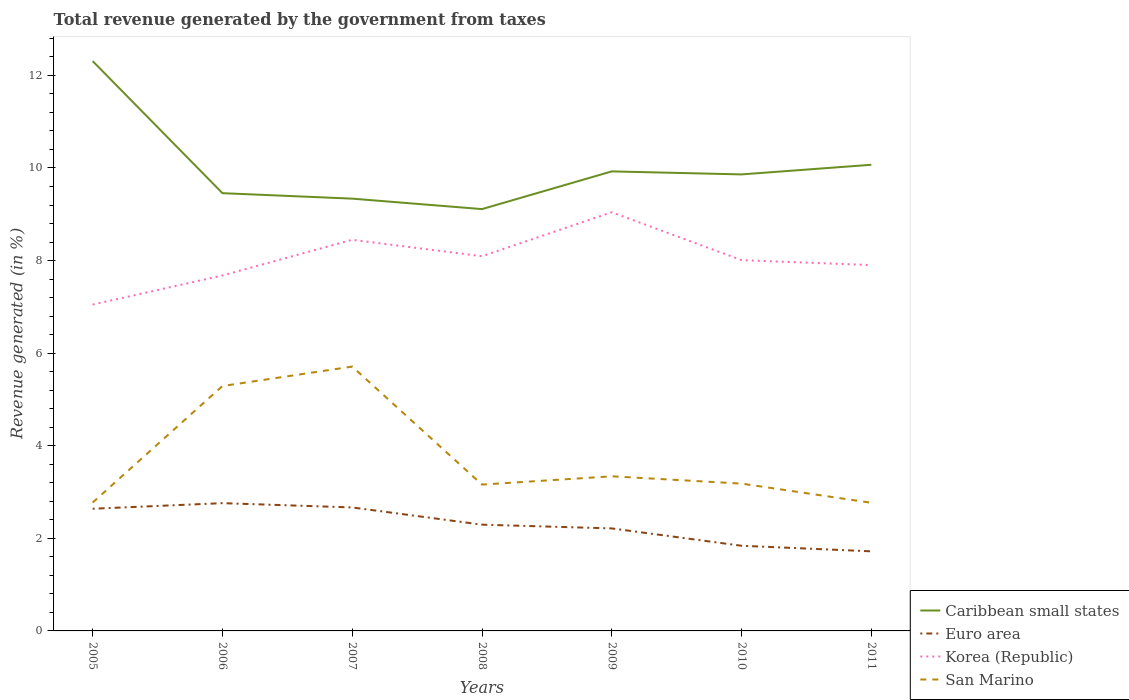Does the line corresponding to Caribbean small states intersect with the line corresponding to Euro area?
Your answer should be compact. No. Is the number of lines equal to the number of legend labels?
Give a very brief answer. Yes. Across all years, what is the maximum total revenue generated in Korea (Republic)?
Offer a terse response. 7.05. In which year was the total revenue generated in San Marino maximum?
Give a very brief answer. 2011. What is the total total revenue generated in Korea (Republic) in the graph?
Your answer should be compact. -1.04. What is the difference between the highest and the second highest total revenue generated in Caribbean small states?
Offer a very short reply. 3.2. What is the difference between the highest and the lowest total revenue generated in Caribbean small states?
Your response must be concise. 2. Does the graph contain grids?
Your response must be concise. No. Where does the legend appear in the graph?
Give a very brief answer. Bottom right. How many legend labels are there?
Give a very brief answer. 4. How are the legend labels stacked?
Your answer should be compact. Vertical. What is the title of the graph?
Keep it short and to the point. Total revenue generated by the government from taxes. Does "Marshall Islands" appear as one of the legend labels in the graph?
Your answer should be very brief. No. What is the label or title of the X-axis?
Offer a very short reply. Years. What is the label or title of the Y-axis?
Offer a very short reply. Revenue generated (in %). What is the Revenue generated (in %) of Caribbean small states in 2005?
Your answer should be compact. 12.31. What is the Revenue generated (in %) of Euro area in 2005?
Give a very brief answer. 2.64. What is the Revenue generated (in %) of Korea (Republic) in 2005?
Make the answer very short. 7.05. What is the Revenue generated (in %) in San Marino in 2005?
Make the answer very short. 2.77. What is the Revenue generated (in %) of Caribbean small states in 2006?
Your answer should be compact. 9.46. What is the Revenue generated (in %) in Euro area in 2006?
Ensure brevity in your answer.  2.76. What is the Revenue generated (in %) of Korea (Republic) in 2006?
Give a very brief answer. 7.68. What is the Revenue generated (in %) of San Marino in 2006?
Offer a very short reply. 5.29. What is the Revenue generated (in %) in Caribbean small states in 2007?
Provide a succinct answer. 9.34. What is the Revenue generated (in %) in Euro area in 2007?
Offer a very short reply. 2.67. What is the Revenue generated (in %) in Korea (Republic) in 2007?
Your answer should be very brief. 8.45. What is the Revenue generated (in %) in San Marino in 2007?
Your answer should be very brief. 5.71. What is the Revenue generated (in %) of Caribbean small states in 2008?
Keep it short and to the point. 9.11. What is the Revenue generated (in %) in Euro area in 2008?
Your answer should be very brief. 2.3. What is the Revenue generated (in %) in Korea (Republic) in 2008?
Keep it short and to the point. 8.09. What is the Revenue generated (in %) in San Marino in 2008?
Your answer should be compact. 3.16. What is the Revenue generated (in %) of Caribbean small states in 2009?
Keep it short and to the point. 9.93. What is the Revenue generated (in %) of Euro area in 2009?
Your answer should be very brief. 2.21. What is the Revenue generated (in %) of Korea (Republic) in 2009?
Provide a short and direct response. 9.04. What is the Revenue generated (in %) in San Marino in 2009?
Keep it short and to the point. 3.34. What is the Revenue generated (in %) in Caribbean small states in 2010?
Give a very brief answer. 9.86. What is the Revenue generated (in %) of Euro area in 2010?
Keep it short and to the point. 1.84. What is the Revenue generated (in %) in Korea (Republic) in 2010?
Offer a very short reply. 8.01. What is the Revenue generated (in %) in San Marino in 2010?
Provide a succinct answer. 3.18. What is the Revenue generated (in %) of Caribbean small states in 2011?
Provide a succinct answer. 10.07. What is the Revenue generated (in %) of Euro area in 2011?
Keep it short and to the point. 1.72. What is the Revenue generated (in %) in Korea (Republic) in 2011?
Give a very brief answer. 7.9. What is the Revenue generated (in %) in San Marino in 2011?
Keep it short and to the point. 2.77. Across all years, what is the maximum Revenue generated (in %) of Caribbean small states?
Provide a short and direct response. 12.31. Across all years, what is the maximum Revenue generated (in %) of Euro area?
Make the answer very short. 2.76. Across all years, what is the maximum Revenue generated (in %) of Korea (Republic)?
Provide a succinct answer. 9.04. Across all years, what is the maximum Revenue generated (in %) in San Marino?
Keep it short and to the point. 5.71. Across all years, what is the minimum Revenue generated (in %) of Caribbean small states?
Provide a short and direct response. 9.11. Across all years, what is the minimum Revenue generated (in %) in Euro area?
Provide a succinct answer. 1.72. Across all years, what is the minimum Revenue generated (in %) of Korea (Republic)?
Provide a short and direct response. 7.05. Across all years, what is the minimum Revenue generated (in %) in San Marino?
Offer a terse response. 2.77. What is the total Revenue generated (in %) of Caribbean small states in the graph?
Give a very brief answer. 70.07. What is the total Revenue generated (in %) in Euro area in the graph?
Ensure brevity in your answer.  16.13. What is the total Revenue generated (in %) of Korea (Republic) in the graph?
Keep it short and to the point. 56.23. What is the total Revenue generated (in %) in San Marino in the graph?
Your answer should be compact. 26.22. What is the difference between the Revenue generated (in %) in Caribbean small states in 2005 and that in 2006?
Provide a succinct answer. 2.85. What is the difference between the Revenue generated (in %) of Euro area in 2005 and that in 2006?
Give a very brief answer. -0.12. What is the difference between the Revenue generated (in %) of Korea (Republic) in 2005 and that in 2006?
Your response must be concise. -0.63. What is the difference between the Revenue generated (in %) in San Marino in 2005 and that in 2006?
Your answer should be very brief. -2.52. What is the difference between the Revenue generated (in %) of Caribbean small states in 2005 and that in 2007?
Ensure brevity in your answer.  2.97. What is the difference between the Revenue generated (in %) of Euro area in 2005 and that in 2007?
Give a very brief answer. -0.03. What is the difference between the Revenue generated (in %) of Korea (Republic) in 2005 and that in 2007?
Your answer should be very brief. -1.4. What is the difference between the Revenue generated (in %) of San Marino in 2005 and that in 2007?
Provide a short and direct response. -2.94. What is the difference between the Revenue generated (in %) of Caribbean small states in 2005 and that in 2008?
Give a very brief answer. 3.2. What is the difference between the Revenue generated (in %) in Euro area in 2005 and that in 2008?
Keep it short and to the point. 0.34. What is the difference between the Revenue generated (in %) in Korea (Republic) in 2005 and that in 2008?
Your response must be concise. -1.04. What is the difference between the Revenue generated (in %) of San Marino in 2005 and that in 2008?
Ensure brevity in your answer.  -0.39. What is the difference between the Revenue generated (in %) in Caribbean small states in 2005 and that in 2009?
Ensure brevity in your answer.  2.38. What is the difference between the Revenue generated (in %) in Euro area in 2005 and that in 2009?
Provide a short and direct response. 0.42. What is the difference between the Revenue generated (in %) in Korea (Republic) in 2005 and that in 2009?
Give a very brief answer. -1.99. What is the difference between the Revenue generated (in %) in San Marino in 2005 and that in 2009?
Give a very brief answer. -0.57. What is the difference between the Revenue generated (in %) in Caribbean small states in 2005 and that in 2010?
Provide a succinct answer. 2.45. What is the difference between the Revenue generated (in %) in Euro area in 2005 and that in 2010?
Provide a succinct answer. 0.8. What is the difference between the Revenue generated (in %) in Korea (Republic) in 2005 and that in 2010?
Provide a succinct answer. -0.96. What is the difference between the Revenue generated (in %) in San Marino in 2005 and that in 2010?
Give a very brief answer. -0.41. What is the difference between the Revenue generated (in %) in Caribbean small states in 2005 and that in 2011?
Give a very brief answer. 2.24. What is the difference between the Revenue generated (in %) of Euro area in 2005 and that in 2011?
Your response must be concise. 0.92. What is the difference between the Revenue generated (in %) of Korea (Republic) in 2005 and that in 2011?
Offer a very short reply. -0.85. What is the difference between the Revenue generated (in %) of San Marino in 2005 and that in 2011?
Give a very brief answer. 0.01. What is the difference between the Revenue generated (in %) in Caribbean small states in 2006 and that in 2007?
Provide a short and direct response. 0.12. What is the difference between the Revenue generated (in %) of Euro area in 2006 and that in 2007?
Provide a short and direct response. 0.09. What is the difference between the Revenue generated (in %) of Korea (Republic) in 2006 and that in 2007?
Ensure brevity in your answer.  -0.77. What is the difference between the Revenue generated (in %) in San Marino in 2006 and that in 2007?
Provide a short and direct response. -0.42. What is the difference between the Revenue generated (in %) in Caribbean small states in 2006 and that in 2008?
Provide a short and direct response. 0.34. What is the difference between the Revenue generated (in %) in Euro area in 2006 and that in 2008?
Provide a short and direct response. 0.46. What is the difference between the Revenue generated (in %) of Korea (Republic) in 2006 and that in 2008?
Provide a succinct answer. -0.42. What is the difference between the Revenue generated (in %) in San Marino in 2006 and that in 2008?
Give a very brief answer. 2.13. What is the difference between the Revenue generated (in %) in Caribbean small states in 2006 and that in 2009?
Offer a terse response. -0.47. What is the difference between the Revenue generated (in %) of Euro area in 2006 and that in 2009?
Offer a very short reply. 0.55. What is the difference between the Revenue generated (in %) in Korea (Republic) in 2006 and that in 2009?
Offer a terse response. -1.37. What is the difference between the Revenue generated (in %) of San Marino in 2006 and that in 2009?
Provide a short and direct response. 1.95. What is the difference between the Revenue generated (in %) in Caribbean small states in 2006 and that in 2010?
Keep it short and to the point. -0.41. What is the difference between the Revenue generated (in %) of Euro area in 2006 and that in 2010?
Make the answer very short. 0.92. What is the difference between the Revenue generated (in %) of Korea (Republic) in 2006 and that in 2010?
Offer a very short reply. -0.33. What is the difference between the Revenue generated (in %) of San Marino in 2006 and that in 2010?
Your answer should be compact. 2.11. What is the difference between the Revenue generated (in %) of Caribbean small states in 2006 and that in 2011?
Provide a succinct answer. -0.61. What is the difference between the Revenue generated (in %) of Euro area in 2006 and that in 2011?
Make the answer very short. 1.04. What is the difference between the Revenue generated (in %) of Korea (Republic) in 2006 and that in 2011?
Your answer should be compact. -0.22. What is the difference between the Revenue generated (in %) in San Marino in 2006 and that in 2011?
Make the answer very short. 2.52. What is the difference between the Revenue generated (in %) in Caribbean small states in 2007 and that in 2008?
Make the answer very short. 0.23. What is the difference between the Revenue generated (in %) in Euro area in 2007 and that in 2008?
Offer a terse response. 0.37. What is the difference between the Revenue generated (in %) in Korea (Republic) in 2007 and that in 2008?
Offer a terse response. 0.35. What is the difference between the Revenue generated (in %) in San Marino in 2007 and that in 2008?
Provide a short and direct response. 2.55. What is the difference between the Revenue generated (in %) in Caribbean small states in 2007 and that in 2009?
Keep it short and to the point. -0.59. What is the difference between the Revenue generated (in %) of Euro area in 2007 and that in 2009?
Offer a very short reply. 0.45. What is the difference between the Revenue generated (in %) of Korea (Republic) in 2007 and that in 2009?
Provide a short and direct response. -0.6. What is the difference between the Revenue generated (in %) in San Marino in 2007 and that in 2009?
Ensure brevity in your answer.  2.37. What is the difference between the Revenue generated (in %) in Caribbean small states in 2007 and that in 2010?
Keep it short and to the point. -0.52. What is the difference between the Revenue generated (in %) in Euro area in 2007 and that in 2010?
Offer a very short reply. 0.83. What is the difference between the Revenue generated (in %) of Korea (Republic) in 2007 and that in 2010?
Your answer should be compact. 0.44. What is the difference between the Revenue generated (in %) of San Marino in 2007 and that in 2010?
Your response must be concise. 2.53. What is the difference between the Revenue generated (in %) of Caribbean small states in 2007 and that in 2011?
Your response must be concise. -0.73. What is the difference between the Revenue generated (in %) in Euro area in 2007 and that in 2011?
Ensure brevity in your answer.  0.95. What is the difference between the Revenue generated (in %) of Korea (Republic) in 2007 and that in 2011?
Keep it short and to the point. 0.55. What is the difference between the Revenue generated (in %) in San Marino in 2007 and that in 2011?
Provide a succinct answer. 2.94. What is the difference between the Revenue generated (in %) in Caribbean small states in 2008 and that in 2009?
Give a very brief answer. -0.81. What is the difference between the Revenue generated (in %) of Euro area in 2008 and that in 2009?
Make the answer very short. 0.08. What is the difference between the Revenue generated (in %) of Korea (Republic) in 2008 and that in 2009?
Provide a short and direct response. -0.95. What is the difference between the Revenue generated (in %) in San Marino in 2008 and that in 2009?
Give a very brief answer. -0.18. What is the difference between the Revenue generated (in %) in Caribbean small states in 2008 and that in 2010?
Offer a terse response. -0.75. What is the difference between the Revenue generated (in %) in Euro area in 2008 and that in 2010?
Provide a succinct answer. 0.46. What is the difference between the Revenue generated (in %) in Korea (Republic) in 2008 and that in 2010?
Provide a short and direct response. 0.09. What is the difference between the Revenue generated (in %) of San Marino in 2008 and that in 2010?
Your response must be concise. -0.02. What is the difference between the Revenue generated (in %) of Caribbean small states in 2008 and that in 2011?
Keep it short and to the point. -0.96. What is the difference between the Revenue generated (in %) of Euro area in 2008 and that in 2011?
Your answer should be compact. 0.58. What is the difference between the Revenue generated (in %) of Korea (Republic) in 2008 and that in 2011?
Your answer should be very brief. 0.19. What is the difference between the Revenue generated (in %) of San Marino in 2008 and that in 2011?
Provide a short and direct response. 0.39. What is the difference between the Revenue generated (in %) in Caribbean small states in 2009 and that in 2010?
Give a very brief answer. 0.07. What is the difference between the Revenue generated (in %) of Euro area in 2009 and that in 2010?
Your answer should be very brief. 0.37. What is the difference between the Revenue generated (in %) in Korea (Republic) in 2009 and that in 2010?
Provide a short and direct response. 1.04. What is the difference between the Revenue generated (in %) in San Marino in 2009 and that in 2010?
Give a very brief answer. 0.16. What is the difference between the Revenue generated (in %) of Caribbean small states in 2009 and that in 2011?
Ensure brevity in your answer.  -0.14. What is the difference between the Revenue generated (in %) in Euro area in 2009 and that in 2011?
Your answer should be compact. 0.49. What is the difference between the Revenue generated (in %) in Korea (Republic) in 2009 and that in 2011?
Offer a very short reply. 1.14. What is the difference between the Revenue generated (in %) of San Marino in 2009 and that in 2011?
Keep it short and to the point. 0.57. What is the difference between the Revenue generated (in %) in Caribbean small states in 2010 and that in 2011?
Your answer should be very brief. -0.21. What is the difference between the Revenue generated (in %) in Euro area in 2010 and that in 2011?
Your response must be concise. 0.12. What is the difference between the Revenue generated (in %) in Korea (Republic) in 2010 and that in 2011?
Offer a very short reply. 0.11. What is the difference between the Revenue generated (in %) of San Marino in 2010 and that in 2011?
Ensure brevity in your answer.  0.41. What is the difference between the Revenue generated (in %) in Caribbean small states in 2005 and the Revenue generated (in %) in Euro area in 2006?
Offer a very short reply. 9.55. What is the difference between the Revenue generated (in %) of Caribbean small states in 2005 and the Revenue generated (in %) of Korea (Republic) in 2006?
Make the answer very short. 4.63. What is the difference between the Revenue generated (in %) of Caribbean small states in 2005 and the Revenue generated (in %) of San Marino in 2006?
Ensure brevity in your answer.  7.02. What is the difference between the Revenue generated (in %) of Euro area in 2005 and the Revenue generated (in %) of Korea (Republic) in 2006?
Make the answer very short. -5.04. What is the difference between the Revenue generated (in %) of Euro area in 2005 and the Revenue generated (in %) of San Marino in 2006?
Your answer should be very brief. -2.65. What is the difference between the Revenue generated (in %) in Korea (Republic) in 2005 and the Revenue generated (in %) in San Marino in 2006?
Make the answer very short. 1.76. What is the difference between the Revenue generated (in %) in Caribbean small states in 2005 and the Revenue generated (in %) in Euro area in 2007?
Provide a short and direct response. 9.64. What is the difference between the Revenue generated (in %) in Caribbean small states in 2005 and the Revenue generated (in %) in Korea (Republic) in 2007?
Your answer should be very brief. 3.86. What is the difference between the Revenue generated (in %) in Caribbean small states in 2005 and the Revenue generated (in %) in San Marino in 2007?
Your response must be concise. 6.6. What is the difference between the Revenue generated (in %) in Euro area in 2005 and the Revenue generated (in %) in Korea (Republic) in 2007?
Give a very brief answer. -5.81. What is the difference between the Revenue generated (in %) of Euro area in 2005 and the Revenue generated (in %) of San Marino in 2007?
Offer a very short reply. -3.07. What is the difference between the Revenue generated (in %) of Korea (Republic) in 2005 and the Revenue generated (in %) of San Marino in 2007?
Provide a succinct answer. 1.34. What is the difference between the Revenue generated (in %) of Caribbean small states in 2005 and the Revenue generated (in %) of Euro area in 2008?
Your response must be concise. 10.01. What is the difference between the Revenue generated (in %) of Caribbean small states in 2005 and the Revenue generated (in %) of Korea (Republic) in 2008?
Keep it short and to the point. 4.21. What is the difference between the Revenue generated (in %) in Caribbean small states in 2005 and the Revenue generated (in %) in San Marino in 2008?
Offer a terse response. 9.15. What is the difference between the Revenue generated (in %) in Euro area in 2005 and the Revenue generated (in %) in Korea (Republic) in 2008?
Offer a terse response. -5.46. What is the difference between the Revenue generated (in %) of Euro area in 2005 and the Revenue generated (in %) of San Marino in 2008?
Provide a succinct answer. -0.52. What is the difference between the Revenue generated (in %) of Korea (Republic) in 2005 and the Revenue generated (in %) of San Marino in 2008?
Ensure brevity in your answer.  3.89. What is the difference between the Revenue generated (in %) of Caribbean small states in 2005 and the Revenue generated (in %) of Euro area in 2009?
Provide a succinct answer. 10.09. What is the difference between the Revenue generated (in %) of Caribbean small states in 2005 and the Revenue generated (in %) of Korea (Republic) in 2009?
Ensure brevity in your answer.  3.26. What is the difference between the Revenue generated (in %) in Caribbean small states in 2005 and the Revenue generated (in %) in San Marino in 2009?
Offer a terse response. 8.97. What is the difference between the Revenue generated (in %) in Euro area in 2005 and the Revenue generated (in %) in Korea (Republic) in 2009?
Make the answer very short. -6.41. What is the difference between the Revenue generated (in %) in Euro area in 2005 and the Revenue generated (in %) in San Marino in 2009?
Give a very brief answer. -0.7. What is the difference between the Revenue generated (in %) of Korea (Republic) in 2005 and the Revenue generated (in %) of San Marino in 2009?
Provide a short and direct response. 3.71. What is the difference between the Revenue generated (in %) in Caribbean small states in 2005 and the Revenue generated (in %) in Euro area in 2010?
Offer a very short reply. 10.47. What is the difference between the Revenue generated (in %) of Caribbean small states in 2005 and the Revenue generated (in %) of Korea (Republic) in 2010?
Provide a short and direct response. 4.3. What is the difference between the Revenue generated (in %) in Caribbean small states in 2005 and the Revenue generated (in %) in San Marino in 2010?
Give a very brief answer. 9.13. What is the difference between the Revenue generated (in %) in Euro area in 2005 and the Revenue generated (in %) in Korea (Republic) in 2010?
Your answer should be compact. -5.37. What is the difference between the Revenue generated (in %) in Euro area in 2005 and the Revenue generated (in %) in San Marino in 2010?
Offer a terse response. -0.54. What is the difference between the Revenue generated (in %) of Korea (Republic) in 2005 and the Revenue generated (in %) of San Marino in 2010?
Give a very brief answer. 3.87. What is the difference between the Revenue generated (in %) of Caribbean small states in 2005 and the Revenue generated (in %) of Euro area in 2011?
Your answer should be very brief. 10.59. What is the difference between the Revenue generated (in %) in Caribbean small states in 2005 and the Revenue generated (in %) in Korea (Republic) in 2011?
Ensure brevity in your answer.  4.41. What is the difference between the Revenue generated (in %) of Caribbean small states in 2005 and the Revenue generated (in %) of San Marino in 2011?
Offer a very short reply. 9.54. What is the difference between the Revenue generated (in %) in Euro area in 2005 and the Revenue generated (in %) in Korea (Republic) in 2011?
Provide a short and direct response. -5.26. What is the difference between the Revenue generated (in %) of Euro area in 2005 and the Revenue generated (in %) of San Marino in 2011?
Provide a short and direct response. -0.13. What is the difference between the Revenue generated (in %) in Korea (Republic) in 2005 and the Revenue generated (in %) in San Marino in 2011?
Provide a short and direct response. 4.28. What is the difference between the Revenue generated (in %) in Caribbean small states in 2006 and the Revenue generated (in %) in Euro area in 2007?
Make the answer very short. 6.79. What is the difference between the Revenue generated (in %) of Caribbean small states in 2006 and the Revenue generated (in %) of Korea (Republic) in 2007?
Make the answer very short. 1.01. What is the difference between the Revenue generated (in %) in Caribbean small states in 2006 and the Revenue generated (in %) in San Marino in 2007?
Offer a terse response. 3.75. What is the difference between the Revenue generated (in %) of Euro area in 2006 and the Revenue generated (in %) of Korea (Republic) in 2007?
Ensure brevity in your answer.  -5.69. What is the difference between the Revenue generated (in %) of Euro area in 2006 and the Revenue generated (in %) of San Marino in 2007?
Ensure brevity in your answer.  -2.95. What is the difference between the Revenue generated (in %) of Korea (Republic) in 2006 and the Revenue generated (in %) of San Marino in 2007?
Make the answer very short. 1.97. What is the difference between the Revenue generated (in %) in Caribbean small states in 2006 and the Revenue generated (in %) in Euro area in 2008?
Your answer should be very brief. 7.16. What is the difference between the Revenue generated (in %) in Caribbean small states in 2006 and the Revenue generated (in %) in Korea (Republic) in 2008?
Provide a short and direct response. 1.36. What is the difference between the Revenue generated (in %) of Caribbean small states in 2006 and the Revenue generated (in %) of San Marino in 2008?
Keep it short and to the point. 6.29. What is the difference between the Revenue generated (in %) of Euro area in 2006 and the Revenue generated (in %) of Korea (Republic) in 2008?
Ensure brevity in your answer.  -5.33. What is the difference between the Revenue generated (in %) of Euro area in 2006 and the Revenue generated (in %) of San Marino in 2008?
Offer a terse response. -0.4. What is the difference between the Revenue generated (in %) in Korea (Republic) in 2006 and the Revenue generated (in %) in San Marino in 2008?
Offer a very short reply. 4.52. What is the difference between the Revenue generated (in %) in Caribbean small states in 2006 and the Revenue generated (in %) in Euro area in 2009?
Offer a terse response. 7.24. What is the difference between the Revenue generated (in %) in Caribbean small states in 2006 and the Revenue generated (in %) in Korea (Republic) in 2009?
Offer a very short reply. 0.41. What is the difference between the Revenue generated (in %) of Caribbean small states in 2006 and the Revenue generated (in %) of San Marino in 2009?
Ensure brevity in your answer.  6.12. What is the difference between the Revenue generated (in %) of Euro area in 2006 and the Revenue generated (in %) of Korea (Republic) in 2009?
Keep it short and to the point. -6.28. What is the difference between the Revenue generated (in %) in Euro area in 2006 and the Revenue generated (in %) in San Marino in 2009?
Provide a short and direct response. -0.58. What is the difference between the Revenue generated (in %) of Korea (Republic) in 2006 and the Revenue generated (in %) of San Marino in 2009?
Keep it short and to the point. 4.34. What is the difference between the Revenue generated (in %) in Caribbean small states in 2006 and the Revenue generated (in %) in Euro area in 2010?
Provide a succinct answer. 7.62. What is the difference between the Revenue generated (in %) in Caribbean small states in 2006 and the Revenue generated (in %) in Korea (Republic) in 2010?
Keep it short and to the point. 1.45. What is the difference between the Revenue generated (in %) of Caribbean small states in 2006 and the Revenue generated (in %) of San Marino in 2010?
Ensure brevity in your answer.  6.27. What is the difference between the Revenue generated (in %) in Euro area in 2006 and the Revenue generated (in %) in Korea (Republic) in 2010?
Provide a succinct answer. -5.25. What is the difference between the Revenue generated (in %) of Euro area in 2006 and the Revenue generated (in %) of San Marino in 2010?
Provide a short and direct response. -0.42. What is the difference between the Revenue generated (in %) of Korea (Republic) in 2006 and the Revenue generated (in %) of San Marino in 2010?
Ensure brevity in your answer.  4.5. What is the difference between the Revenue generated (in %) of Caribbean small states in 2006 and the Revenue generated (in %) of Euro area in 2011?
Keep it short and to the point. 7.74. What is the difference between the Revenue generated (in %) in Caribbean small states in 2006 and the Revenue generated (in %) in Korea (Republic) in 2011?
Your answer should be compact. 1.55. What is the difference between the Revenue generated (in %) of Caribbean small states in 2006 and the Revenue generated (in %) of San Marino in 2011?
Offer a very short reply. 6.69. What is the difference between the Revenue generated (in %) in Euro area in 2006 and the Revenue generated (in %) in Korea (Republic) in 2011?
Provide a succinct answer. -5.14. What is the difference between the Revenue generated (in %) in Euro area in 2006 and the Revenue generated (in %) in San Marino in 2011?
Your answer should be compact. -0.01. What is the difference between the Revenue generated (in %) of Korea (Republic) in 2006 and the Revenue generated (in %) of San Marino in 2011?
Make the answer very short. 4.91. What is the difference between the Revenue generated (in %) of Caribbean small states in 2007 and the Revenue generated (in %) of Euro area in 2008?
Provide a succinct answer. 7.04. What is the difference between the Revenue generated (in %) in Caribbean small states in 2007 and the Revenue generated (in %) in Korea (Republic) in 2008?
Provide a short and direct response. 1.24. What is the difference between the Revenue generated (in %) in Caribbean small states in 2007 and the Revenue generated (in %) in San Marino in 2008?
Give a very brief answer. 6.18. What is the difference between the Revenue generated (in %) of Euro area in 2007 and the Revenue generated (in %) of Korea (Republic) in 2008?
Keep it short and to the point. -5.43. What is the difference between the Revenue generated (in %) of Euro area in 2007 and the Revenue generated (in %) of San Marino in 2008?
Your answer should be very brief. -0.49. What is the difference between the Revenue generated (in %) of Korea (Republic) in 2007 and the Revenue generated (in %) of San Marino in 2008?
Provide a short and direct response. 5.29. What is the difference between the Revenue generated (in %) in Caribbean small states in 2007 and the Revenue generated (in %) in Euro area in 2009?
Give a very brief answer. 7.12. What is the difference between the Revenue generated (in %) of Caribbean small states in 2007 and the Revenue generated (in %) of Korea (Republic) in 2009?
Your response must be concise. 0.29. What is the difference between the Revenue generated (in %) in Caribbean small states in 2007 and the Revenue generated (in %) in San Marino in 2009?
Provide a succinct answer. 6. What is the difference between the Revenue generated (in %) in Euro area in 2007 and the Revenue generated (in %) in Korea (Republic) in 2009?
Your answer should be very brief. -6.38. What is the difference between the Revenue generated (in %) of Euro area in 2007 and the Revenue generated (in %) of San Marino in 2009?
Give a very brief answer. -0.67. What is the difference between the Revenue generated (in %) in Korea (Republic) in 2007 and the Revenue generated (in %) in San Marino in 2009?
Offer a terse response. 5.11. What is the difference between the Revenue generated (in %) of Caribbean small states in 2007 and the Revenue generated (in %) of Euro area in 2010?
Keep it short and to the point. 7.5. What is the difference between the Revenue generated (in %) of Caribbean small states in 2007 and the Revenue generated (in %) of Korea (Republic) in 2010?
Give a very brief answer. 1.33. What is the difference between the Revenue generated (in %) of Caribbean small states in 2007 and the Revenue generated (in %) of San Marino in 2010?
Your answer should be very brief. 6.16. What is the difference between the Revenue generated (in %) of Euro area in 2007 and the Revenue generated (in %) of Korea (Republic) in 2010?
Your answer should be compact. -5.34. What is the difference between the Revenue generated (in %) in Euro area in 2007 and the Revenue generated (in %) in San Marino in 2010?
Offer a very short reply. -0.52. What is the difference between the Revenue generated (in %) in Korea (Republic) in 2007 and the Revenue generated (in %) in San Marino in 2010?
Provide a short and direct response. 5.27. What is the difference between the Revenue generated (in %) in Caribbean small states in 2007 and the Revenue generated (in %) in Euro area in 2011?
Your answer should be compact. 7.62. What is the difference between the Revenue generated (in %) of Caribbean small states in 2007 and the Revenue generated (in %) of Korea (Republic) in 2011?
Your response must be concise. 1.44. What is the difference between the Revenue generated (in %) of Caribbean small states in 2007 and the Revenue generated (in %) of San Marino in 2011?
Your answer should be very brief. 6.57. What is the difference between the Revenue generated (in %) in Euro area in 2007 and the Revenue generated (in %) in Korea (Republic) in 2011?
Make the answer very short. -5.24. What is the difference between the Revenue generated (in %) in Euro area in 2007 and the Revenue generated (in %) in San Marino in 2011?
Offer a terse response. -0.1. What is the difference between the Revenue generated (in %) in Korea (Republic) in 2007 and the Revenue generated (in %) in San Marino in 2011?
Ensure brevity in your answer.  5.68. What is the difference between the Revenue generated (in %) of Caribbean small states in 2008 and the Revenue generated (in %) of Euro area in 2009?
Provide a short and direct response. 6.9. What is the difference between the Revenue generated (in %) in Caribbean small states in 2008 and the Revenue generated (in %) in Korea (Republic) in 2009?
Ensure brevity in your answer.  0.07. What is the difference between the Revenue generated (in %) of Caribbean small states in 2008 and the Revenue generated (in %) of San Marino in 2009?
Give a very brief answer. 5.77. What is the difference between the Revenue generated (in %) of Euro area in 2008 and the Revenue generated (in %) of Korea (Republic) in 2009?
Make the answer very short. -6.75. What is the difference between the Revenue generated (in %) of Euro area in 2008 and the Revenue generated (in %) of San Marino in 2009?
Keep it short and to the point. -1.04. What is the difference between the Revenue generated (in %) of Korea (Republic) in 2008 and the Revenue generated (in %) of San Marino in 2009?
Provide a succinct answer. 4.75. What is the difference between the Revenue generated (in %) in Caribbean small states in 2008 and the Revenue generated (in %) in Euro area in 2010?
Give a very brief answer. 7.27. What is the difference between the Revenue generated (in %) of Caribbean small states in 2008 and the Revenue generated (in %) of Korea (Republic) in 2010?
Provide a short and direct response. 1.1. What is the difference between the Revenue generated (in %) of Caribbean small states in 2008 and the Revenue generated (in %) of San Marino in 2010?
Your response must be concise. 5.93. What is the difference between the Revenue generated (in %) in Euro area in 2008 and the Revenue generated (in %) in Korea (Republic) in 2010?
Your answer should be very brief. -5.71. What is the difference between the Revenue generated (in %) of Euro area in 2008 and the Revenue generated (in %) of San Marino in 2010?
Your answer should be compact. -0.89. What is the difference between the Revenue generated (in %) in Korea (Republic) in 2008 and the Revenue generated (in %) in San Marino in 2010?
Give a very brief answer. 4.91. What is the difference between the Revenue generated (in %) in Caribbean small states in 2008 and the Revenue generated (in %) in Euro area in 2011?
Provide a succinct answer. 7.39. What is the difference between the Revenue generated (in %) in Caribbean small states in 2008 and the Revenue generated (in %) in Korea (Republic) in 2011?
Provide a succinct answer. 1.21. What is the difference between the Revenue generated (in %) of Caribbean small states in 2008 and the Revenue generated (in %) of San Marino in 2011?
Ensure brevity in your answer.  6.34. What is the difference between the Revenue generated (in %) of Euro area in 2008 and the Revenue generated (in %) of Korea (Republic) in 2011?
Make the answer very short. -5.61. What is the difference between the Revenue generated (in %) in Euro area in 2008 and the Revenue generated (in %) in San Marino in 2011?
Provide a short and direct response. -0.47. What is the difference between the Revenue generated (in %) of Korea (Republic) in 2008 and the Revenue generated (in %) of San Marino in 2011?
Your answer should be compact. 5.33. What is the difference between the Revenue generated (in %) in Caribbean small states in 2009 and the Revenue generated (in %) in Euro area in 2010?
Your answer should be very brief. 8.09. What is the difference between the Revenue generated (in %) of Caribbean small states in 2009 and the Revenue generated (in %) of Korea (Republic) in 2010?
Give a very brief answer. 1.92. What is the difference between the Revenue generated (in %) in Caribbean small states in 2009 and the Revenue generated (in %) in San Marino in 2010?
Keep it short and to the point. 6.74. What is the difference between the Revenue generated (in %) in Euro area in 2009 and the Revenue generated (in %) in Korea (Republic) in 2010?
Ensure brevity in your answer.  -5.79. What is the difference between the Revenue generated (in %) of Euro area in 2009 and the Revenue generated (in %) of San Marino in 2010?
Make the answer very short. -0.97. What is the difference between the Revenue generated (in %) in Korea (Republic) in 2009 and the Revenue generated (in %) in San Marino in 2010?
Keep it short and to the point. 5.86. What is the difference between the Revenue generated (in %) of Caribbean small states in 2009 and the Revenue generated (in %) of Euro area in 2011?
Your answer should be very brief. 8.21. What is the difference between the Revenue generated (in %) of Caribbean small states in 2009 and the Revenue generated (in %) of Korea (Republic) in 2011?
Your response must be concise. 2.02. What is the difference between the Revenue generated (in %) of Caribbean small states in 2009 and the Revenue generated (in %) of San Marino in 2011?
Provide a succinct answer. 7.16. What is the difference between the Revenue generated (in %) in Euro area in 2009 and the Revenue generated (in %) in Korea (Republic) in 2011?
Offer a terse response. -5.69. What is the difference between the Revenue generated (in %) in Euro area in 2009 and the Revenue generated (in %) in San Marino in 2011?
Offer a terse response. -0.55. What is the difference between the Revenue generated (in %) of Korea (Republic) in 2009 and the Revenue generated (in %) of San Marino in 2011?
Give a very brief answer. 6.28. What is the difference between the Revenue generated (in %) of Caribbean small states in 2010 and the Revenue generated (in %) of Euro area in 2011?
Your response must be concise. 8.14. What is the difference between the Revenue generated (in %) in Caribbean small states in 2010 and the Revenue generated (in %) in Korea (Republic) in 2011?
Offer a very short reply. 1.96. What is the difference between the Revenue generated (in %) in Caribbean small states in 2010 and the Revenue generated (in %) in San Marino in 2011?
Provide a succinct answer. 7.09. What is the difference between the Revenue generated (in %) in Euro area in 2010 and the Revenue generated (in %) in Korea (Republic) in 2011?
Offer a terse response. -6.06. What is the difference between the Revenue generated (in %) in Euro area in 2010 and the Revenue generated (in %) in San Marino in 2011?
Offer a terse response. -0.93. What is the difference between the Revenue generated (in %) of Korea (Republic) in 2010 and the Revenue generated (in %) of San Marino in 2011?
Your answer should be very brief. 5.24. What is the average Revenue generated (in %) of Caribbean small states per year?
Offer a very short reply. 10.01. What is the average Revenue generated (in %) in Euro area per year?
Your answer should be compact. 2.31. What is the average Revenue generated (in %) in Korea (Republic) per year?
Provide a succinct answer. 8.03. What is the average Revenue generated (in %) in San Marino per year?
Your answer should be compact. 3.75. In the year 2005, what is the difference between the Revenue generated (in %) in Caribbean small states and Revenue generated (in %) in Euro area?
Make the answer very short. 9.67. In the year 2005, what is the difference between the Revenue generated (in %) in Caribbean small states and Revenue generated (in %) in Korea (Republic)?
Give a very brief answer. 5.26. In the year 2005, what is the difference between the Revenue generated (in %) in Caribbean small states and Revenue generated (in %) in San Marino?
Ensure brevity in your answer.  9.54. In the year 2005, what is the difference between the Revenue generated (in %) in Euro area and Revenue generated (in %) in Korea (Republic)?
Offer a very short reply. -4.41. In the year 2005, what is the difference between the Revenue generated (in %) of Euro area and Revenue generated (in %) of San Marino?
Offer a terse response. -0.13. In the year 2005, what is the difference between the Revenue generated (in %) of Korea (Republic) and Revenue generated (in %) of San Marino?
Provide a short and direct response. 4.28. In the year 2006, what is the difference between the Revenue generated (in %) in Caribbean small states and Revenue generated (in %) in Euro area?
Provide a succinct answer. 6.7. In the year 2006, what is the difference between the Revenue generated (in %) in Caribbean small states and Revenue generated (in %) in Korea (Republic)?
Ensure brevity in your answer.  1.78. In the year 2006, what is the difference between the Revenue generated (in %) of Caribbean small states and Revenue generated (in %) of San Marino?
Keep it short and to the point. 4.17. In the year 2006, what is the difference between the Revenue generated (in %) in Euro area and Revenue generated (in %) in Korea (Republic)?
Keep it short and to the point. -4.92. In the year 2006, what is the difference between the Revenue generated (in %) in Euro area and Revenue generated (in %) in San Marino?
Offer a terse response. -2.53. In the year 2006, what is the difference between the Revenue generated (in %) of Korea (Republic) and Revenue generated (in %) of San Marino?
Offer a terse response. 2.39. In the year 2007, what is the difference between the Revenue generated (in %) in Caribbean small states and Revenue generated (in %) in Euro area?
Your response must be concise. 6.67. In the year 2007, what is the difference between the Revenue generated (in %) in Caribbean small states and Revenue generated (in %) in Korea (Republic)?
Give a very brief answer. 0.89. In the year 2007, what is the difference between the Revenue generated (in %) in Caribbean small states and Revenue generated (in %) in San Marino?
Keep it short and to the point. 3.63. In the year 2007, what is the difference between the Revenue generated (in %) in Euro area and Revenue generated (in %) in Korea (Republic)?
Provide a succinct answer. -5.78. In the year 2007, what is the difference between the Revenue generated (in %) in Euro area and Revenue generated (in %) in San Marino?
Keep it short and to the point. -3.04. In the year 2007, what is the difference between the Revenue generated (in %) in Korea (Republic) and Revenue generated (in %) in San Marino?
Keep it short and to the point. 2.74. In the year 2008, what is the difference between the Revenue generated (in %) of Caribbean small states and Revenue generated (in %) of Euro area?
Keep it short and to the point. 6.82. In the year 2008, what is the difference between the Revenue generated (in %) of Caribbean small states and Revenue generated (in %) of Korea (Republic)?
Make the answer very short. 1.02. In the year 2008, what is the difference between the Revenue generated (in %) of Caribbean small states and Revenue generated (in %) of San Marino?
Make the answer very short. 5.95. In the year 2008, what is the difference between the Revenue generated (in %) of Euro area and Revenue generated (in %) of Korea (Republic)?
Your response must be concise. -5.8. In the year 2008, what is the difference between the Revenue generated (in %) of Euro area and Revenue generated (in %) of San Marino?
Offer a terse response. -0.87. In the year 2008, what is the difference between the Revenue generated (in %) in Korea (Republic) and Revenue generated (in %) in San Marino?
Your answer should be compact. 4.93. In the year 2009, what is the difference between the Revenue generated (in %) in Caribbean small states and Revenue generated (in %) in Euro area?
Offer a terse response. 7.71. In the year 2009, what is the difference between the Revenue generated (in %) of Caribbean small states and Revenue generated (in %) of Korea (Republic)?
Provide a short and direct response. 0.88. In the year 2009, what is the difference between the Revenue generated (in %) of Caribbean small states and Revenue generated (in %) of San Marino?
Your answer should be very brief. 6.59. In the year 2009, what is the difference between the Revenue generated (in %) in Euro area and Revenue generated (in %) in Korea (Republic)?
Your response must be concise. -6.83. In the year 2009, what is the difference between the Revenue generated (in %) of Euro area and Revenue generated (in %) of San Marino?
Offer a very short reply. -1.13. In the year 2009, what is the difference between the Revenue generated (in %) in Korea (Republic) and Revenue generated (in %) in San Marino?
Your answer should be compact. 5.7. In the year 2010, what is the difference between the Revenue generated (in %) of Caribbean small states and Revenue generated (in %) of Euro area?
Your answer should be very brief. 8.02. In the year 2010, what is the difference between the Revenue generated (in %) in Caribbean small states and Revenue generated (in %) in Korea (Republic)?
Offer a very short reply. 1.85. In the year 2010, what is the difference between the Revenue generated (in %) in Caribbean small states and Revenue generated (in %) in San Marino?
Your response must be concise. 6.68. In the year 2010, what is the difference between the Revenue generated (in %) of Euro area and Revenue generated (in %) of Korea (Republic)?
Ensure brevity in your answer.  -6.17. In the year 2010, what is the difference between the Revenue generated (in %) of Euro area and Revenue generated (in %) of San Marino?
Offer a very short reply. -1.34. In the year 2010, what is the difference between the Revenue generated (in %) of Korea (Republic) and Revenue generated (in %) of San Marino?
Your response must be concise. 4.83. In the year 2011, what is the difference between the Revenue generated (in %) of Caribbean small states and Revenue generated (in %) of Euro area?
Offer a terse response. 8.35. In the year 2011, what is the difference between the Revenue generated (in %) in Caribbean small states and Revenue generated (in %) in Korea (Republic)?
Your answer should be very brief. 2.17. In the year 2011, what is the difference between the Revenue generated (in %) of Caribbean small states and Revenue generated (in %) of San Marino?
Make the answer very short. 7.3. In the year 2011, what is the difference between the Revenue generated (in %) in Euro area and Revenue generated (in %) in Korea (Republic)?
Provide a short and direct response. -6.18. In the year 2011, what is the difference between the Revenue generated (in %) in Euro area and Revenue generated (in %) in San Marino?
Your answer should be very brief. -1.05. In the year 2011, what is the difference between the Revenue generated (in %) in Korea (Republic) and Revenue generated (in %) in San Marino?
Make the answer very short. 5.13. What is the ratio of the Revenue generated (in %) of Caribbean small states in 2005 to that in 2006?
Your answer should be very brief. 1.3. What is the ratio of the Revenue generated (in %) of Euro area in 2005 to that in 2006?
Make the answer very short. 0.96. What is the ratio of the Revenue generated (in %) of Korea (Republic) in 2005 to that in 2006?
Offer a very short reply. 0.92. What is the ratio of the Revenue generated (in %) in San Marino in 2005 to that in 2006?
Your answer should be compact. 0.52. What is the ratio of the Revenue generated (in %) in Caribbean small states in 2005 to that in 2007?
Provide a succinct answer. 1.32. What is the ratio of the Revenue generated (in %) in Korea (Republic) in 2005 to that in 2007?
Ensure brevity in your answer.  0.83. What is the ratio of the Revenue generated (in %) of San Marino in 2005 to that in 2007?
Your answer should be very brief. 0.49. What is the ratio of the Revenue generated (in %) in Caribbean small states in 2005 to that in 2008?
Your response must be concise. 1.35. What is the ratio of the Revenue generated (in %) of Euro area in 2005 to that in 2008?
Your answer should be very brief. 1.15. What is the ratio of the Revenue generated (in %) of Korea (Republic) in 2005 to that in 2008?
Keep it short and to the point. 0.87. What is the ratio of the Revenue generated (in %) in San Marino in 2005 to that in 2008?
Offer a very short reply. 0.88. What is the ratio of the Revenue generated (in %) of Caribbean small states in 2005 to that in 2009?
Provide a short and direct response. 1.24. What is the ratio of the Revenue generated (in %) in Euro area in 2005 to that in 2009?
Offer a very short reply. 1.19. What is the ratio of the Revenue generated (in %) of Korea (Republic) in 2005 to that in 2009?
Offer a very short reply. 0.78. What is the ratio of the Revenue generated (in %) in San Marino in 2005 to that in 2009?
Provide a succinct answer. 0.83. What is the ratio of the Revenue generated (in %) in Caribbean small states in 2005 to that in 2010?
Your answer should be very brief. 1.25. What is the ratio of the Revenue generated (in %) in Euro area in 2005 to that in 2010?
Ensure brevity in your answer.  1.43. What is the ratio of the Revenue generated (in %) in Korea (Republic) in 2005 to that in 2010?
Your response must be concise. 0.88. What is the ratio of the Revenue generated (in %) in San Marino in 2005 to that in 2010?
Your response must be concise. 0.87. What is the ratio of the Revenue generated (in %) in Caribbean small states in 2005 to that in 2011?
Provide a succinct answer. 1.22. What is the ratio of the Revenue generated (in %) of Euro area in 2005 to that in 2011?
Provide a short and direct response. 1.54. What is the ratio of the Revenue generated (in %) in Korea (Republic) in 2005 to that in 2011?
Give a very brief answer. 0.89. What is the ratio of the Revenue generated (in %) of San Marino in 2005 to that in 2011?
Keep it short and to the point. 1. What is the ratio of the Revenue generated (in %) in Caribbean small states in 2006 to that in 2007?
Offer a terse response. 1.01. What is the ratio of the Revenue generated (in %) in Euro area in 2006 to that in 2007?
Give a very brief answer. 1.03. What is the ratio of the Revenue generated (in %) in Korea (Republic) in 2006 to that in 2007?
Offer a terse response. 0.91. What is the ratio of the Revenue generated (in %) in San Marino in 2006 to that in 2007?
Ensure brevity in your answer.  0.93. What is the ratio of the Revenue generated (in %) of Caribbean small states in 2006 to that in 2008?
Offer a very short reply. 1.04. What is the ratio of the Revenue generated (in %) in Euro area in 2006 to that in 2008?
Your response must be concise. 1.2. What is the ratio of the Revenue generated (in %) of Korea (Republic) in 2006 to that in 2008?
Provide a short and direct response. 0.95. What is the ratio of the Revenue generated (in %) in San Marino in 2006 to that in 2008?
Make the answer very short. 1.67. What is the ratio of the Revenue generated (in %) of Caribbean small states in 2006 to that in 2009?
Make the answer very short. 0.95. What is the ratio of the Revenue generated (in %) in Euro area in 2006 to that in 2009?
Offer a terse response. 1.25. What is the ratio of the Revenue generated (in %) of Korea (Republic) in 2006 to that in 2009?
Give a very brief answer. 0.85. What is the ratio of the Revenue generated (in %) of San Marino in 2006 to that in 2009?
Keep it short and to the point. 1.58. What is the ratio of the Revenue generated (in %) in Caribbean small states in 2006 to that in 2010?
Ensure brevity in your answer.  0.96. What is the ratio of the Revenue generated (in %) of Euro area in 2006 to that in 2010?
Ensure brevity in your answer.  1.5. What is the ratio of the Revenue generated (in %) in Korea (Republic) in 2006 to that in 2010?
Make the answer very short. 0.96. What is the ratio of the Revenue generated (in %) in San Marino in 2006 to that in 2010?
Your response must be concise. 1.66. What is the ratio of the Revenue generated (in %) of Caribbean small states in 2006 to that in 2011?
Ensure brevity in your answer.  0.94. What is the ratio of the Revenue generated (in %) in Euro area in 2006 to that in 2011?
Your answer should be compact. 1.61. What is the ratio of the Revenue generated (in %) of Korea (Republic) in 2006 to that in 2011?
Your answer should be compact. 0.97. What is the ratio of the Revenue generated (in %) in San Marino in 2006 to that in 2011?
Provide a succinct answer. 1.91. What is the ratio of the Revenue generated (in %) of Caribbean small states in 2007 to that in 2008?
Keep it short and to the point. 1.02. What is the ratio of the Revenue generated (in %) of Euro area in 2007 to that in 2008?
Ensure brevity in your answer.  1.16. What is the ratio of the Revenue generated (in %) in Korea (Republic) in 2007 to that in 2008?
Ensure brevity in your answer.  1.04. What is the ratio of the Revenue generated (in %) in San Marino in 2007 to that in 2008?
Provide a succinct answer. 1.81. What is the ratio of the Revenue generated (in %) of Caribbean small states in 2007 to that in 2009?
Ensure brevity in your answer.  0.94. What is the ratio of the Revenue generated (in %) of Euro area in 2007 to that in 2009?
Provide a short and direct response. 1.2. What is the ratio of the Revenue generated (in %) in Korea (Republic) in 2007 to that in 2009?
Provide a short and direct response. 0.93. What is the ratio of the Revenue generated (in %) of San Marino in 2007 to that in 2009?
Make the answer very short. 1.71. What is the ratio of the Revenue generated (in %) of Caribbean small states in 2007 to that in 2010?
Provide a succinct answer. 0.95. What is the ratio of the Revenue generated (in %) in Euro area in 2007 to that in 2010?
Provide a short and direct response. 1.45. What is the ratio of the Revenue generated (in %) in Korea (Republic) in 2007 to that in 2010?
Your response must be concise. 1.05. What is the ratio of the Revenue generated (in %) of San Marino in 2007 to that in 2010?
Your answer should be compact. 1.79. What is the ratio of the Revenue generated (in %) in Caribbean small states in 2007 to that in 2011?
Your response must be concise. 0.93. What is the ratio of the Revenue generated (in %) in Euro area in 2007 to that in 2011?
Make the answer very short. 1.55. What is the ratio of the Revenue generated (in %) in Korea (Republic) in 2007 to that in 2011?
Your answer should be compact. 1.07. What is the ratio of the Revenue generated (in %) of San Marino in 2007 to that in 2011?
Your answer should be compact. 2.06. What is the ratio of the Revenue generated (in %) in Caribbean small states in 2008 to that in 2009?
Provide a short and direct response. 0.92. What is the ratio of the Revenue generated (in %) of Euro area in 2008 to that in 2009?
Ensure brevity in your answer.  1.04. What is the ratio of the Revenue generated (in %) in Korea (Republic) in 2008 to that in 2009?
Your answer should be compact. 0.9. What is the ratio of the Revenue generated (in %) in San Marino in 2008 to that in 2009?
Give a very brief answer. 0.95. What is the ratio of the Revenue generated (in %) in Caribbean small states in 2008 to that in 2010?
Make the answer very short. 0.92. What is the ratio of the Revenue generated (in %) in Euro area in 2008 to that in 2010?
Offer a very short reply. 1.25. What is the ratio of the Revenue generated (in %) in Korea (Republic) in 2008 to that in 2010?
Ensure brevity in your answer.  1.01. What is the ratio of the Revenue generated (in %) of San Marino in 2008 to that in 2010?
Ensure brevity in your answer.  0.99. What is the ratio of the Revenue generated (in %) of Caribbean small states in 2008 to that in 2011?
Your answer should be very brief. 0.9. What is the ratio of the Revenue generated (in %) of Euro area in 2008 to that in 2011?
Offer a very short reply. 1.34. What is the ratio of the Revenue generated (in %) in Korea (Republic) in 2008 to that in 2011?
Offer a terse response. 1.02. What is the ratio of the Revenue generated (in %) in San Marino in 2008 to that in 2011?
Your answer should be very brief. 1.14. What is the ratio of the Revenue generated (in %) in Caribbean small states in 2009 to that in 2010?
Provide a succinct answer. 1.01. What is the ratio of the Revenue generated (in %) in Euro area in 2009 to that in 2010?
Keep it short and to the point. 1.2. What is the ratio of the Revenue generated (in %) in Korea (Republic) in 2009 to that in 2010?
Keep it short and to the point. 1.13. What is the ratio of the Revenue generated (in %) in San Marino in 2009 to that in 2010?
Your answer should be very brief. 1.05. What is the ratio of the Revenue generated (in %) in Caribbean small states in 2009 to that in 2011?
Make the answer very short. 0.99. What is the ratio of the Revenue generated (in %) of Euro area in 2009 to that in 2011?
Provide a short and direct response. 1.29. What is the ratio of the Revenue generated (in %) in Korea (Republic) in 2009 to that in 2011?
Provide a short and direct response. 1.14. What is the ratio of the Revenue generated (in %) in San Marino in 2009 to that in 2011?
Your answer should be compact. 1.21. What is the ratio of the Revenue generated (in %) of Caribbean small states in 2010 to that in 2011?
Your answer should be very brief. 0.98. What is the ratio of the Revenue generated (in %) of Euro area in 2010 to that in 2011?
Your answer should be compact. 1.07. What is the ratio of the Revenue generated (in %) of Korea (Republic) in 2010 to that in 2011?
Offer a terse response. 1.01. What is the ratio of the Revenue generated (in %) in San Marino in 2010 to that in 2011?
Ensure brevity in your answer.  1.15. What is the difference between the highest and the second highest Revenue generated (in %) in Caribbean small states?
Provide a succinct answer. 2.24. What is the difference between the highest and the second highest Revenue generated (in %) in Euro area?
Make the answer very short. 0.09. What is the difference between the highest and the second highest Revenue generated (in %) of Korea (Republic)?
Your answer should be very brief. 0.6. What is the difference between the highest and the second highest Revenue generated (in %) of San Marino?
Give a very brief answer. 0.42. What is the difference between the highest and the lowest Revenue generated (in %) in Caribbean small states?
Give a very brief answer. 3.2. What is the difference between the highest and the lowest Revenue generated (in %) of Euro area?
Your response must be concise. 1.04. What is the difference between the highest and the lowest Revenue generated (in %) of Korea (Republic)?
Your answer should be very brief. 1.99. What is the difference between the highest and the lowest Revenue generated (in %) of San Marino?
Your answer should be very brief. 2.94. 